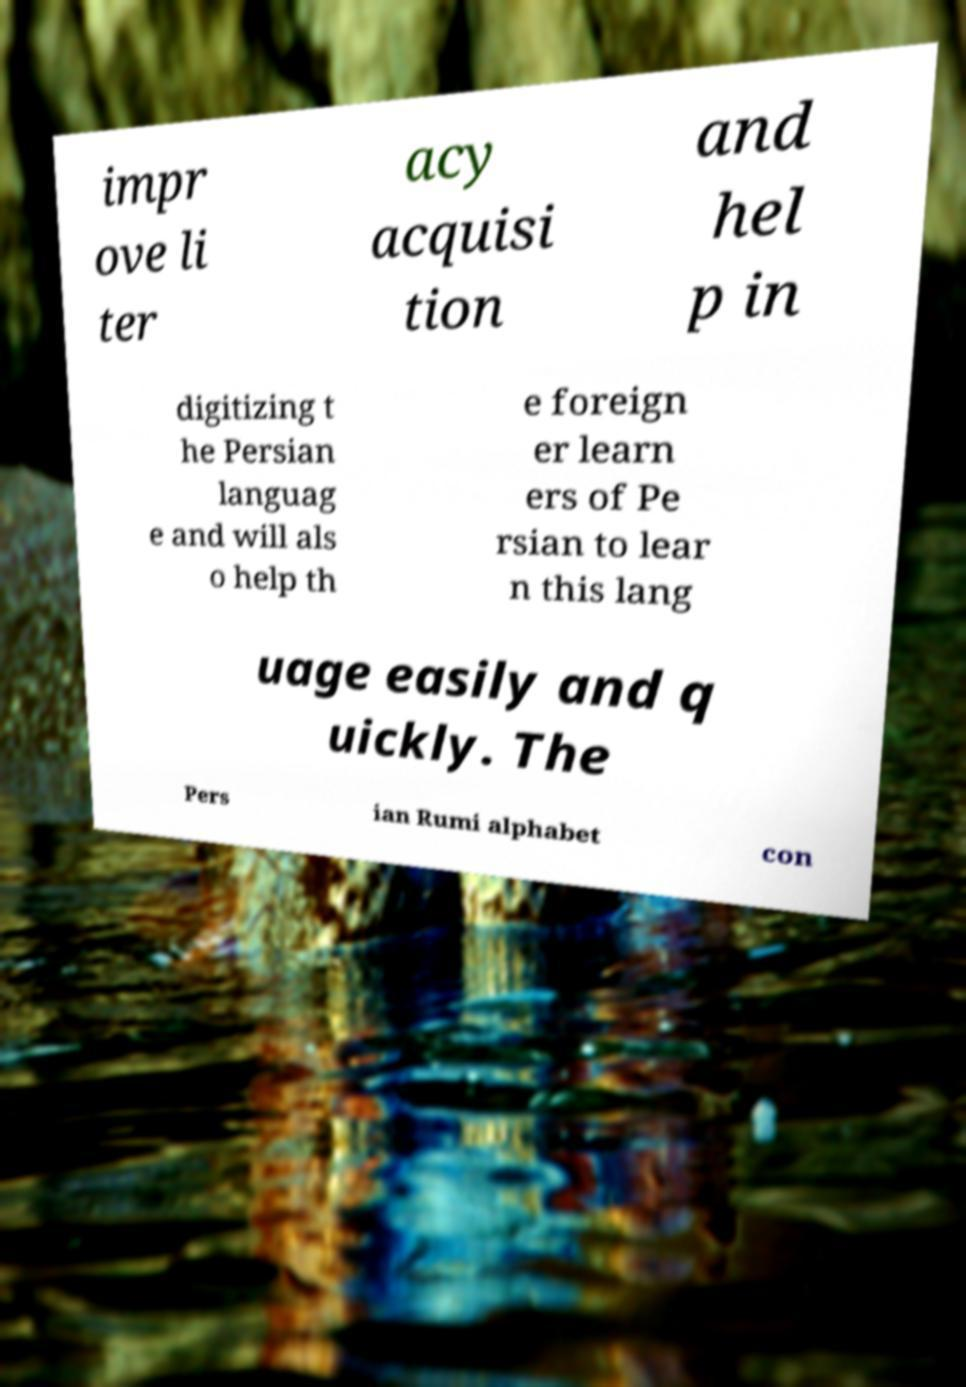There's text embedded in this image that I need extracted. Can you transcribe it verbatim? impr ove li ter acy acquisi tion and hel p in digitizing t he Persian languag e and will als o help th e foreign er learn ers of Pe rsian to lear n this lang uage easily and q uickly. The Pers ian Rumi alphabet con 